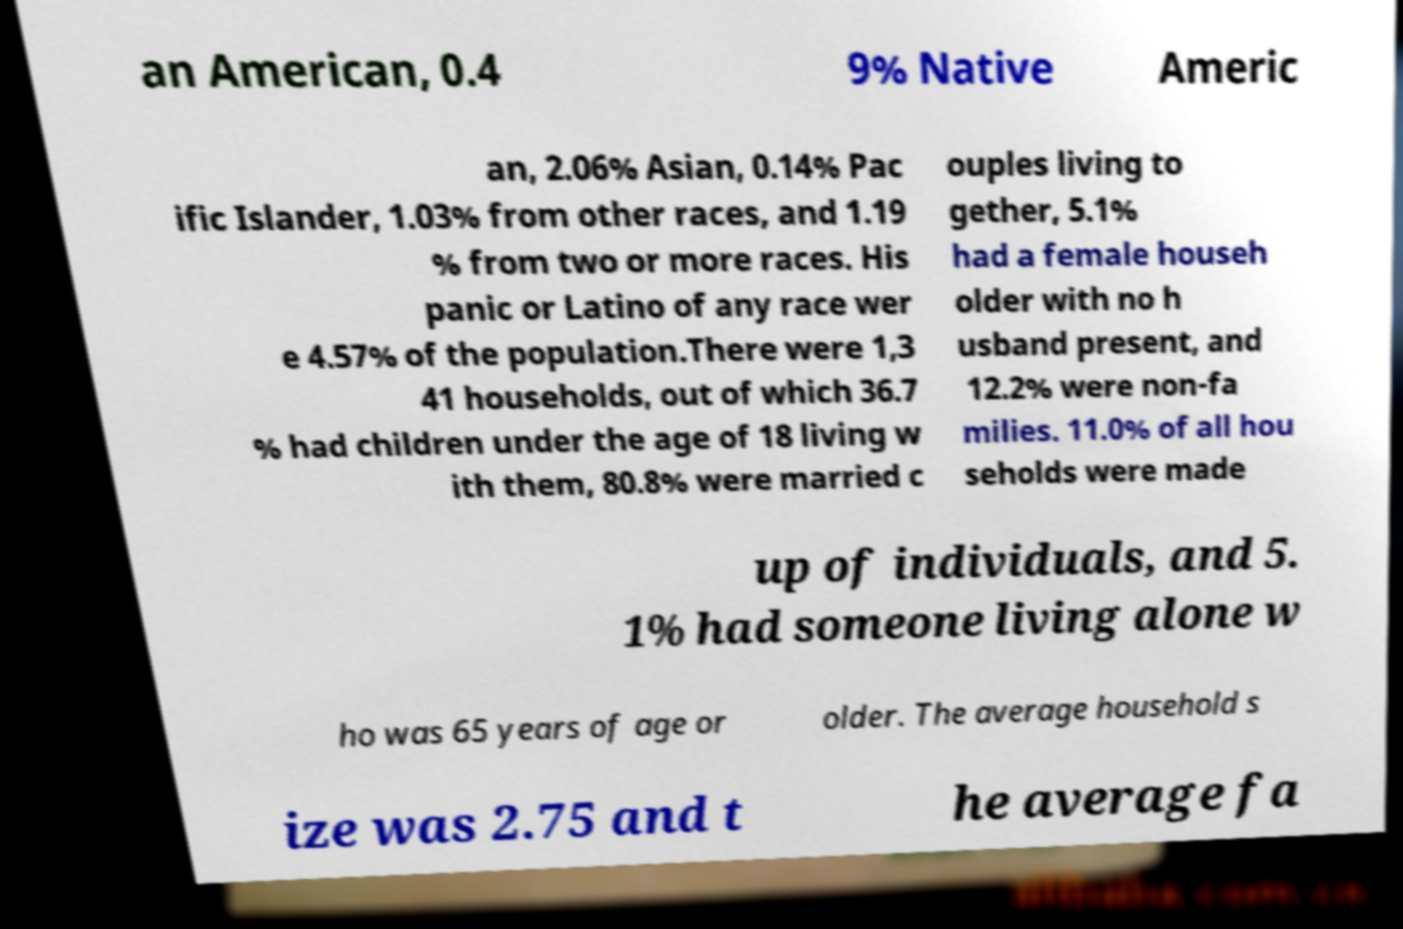Could you extract and type out the text from this image? an American, 0.4 9% Native Americ an, 2.06% Asian, 0.14% Pac ific Islander, 1.03% from other races, and 1.19 % from two or more races. His panic or Latino of any race wer e 4.57% of the population.There were 1,3 41 households, out of which 36.7 % had children under the age of 18 living w ith them, 80.8% were married c ouples living to gether, 5.1% had a female househ older with no h usband present, and 12.2% were non-fa milies. 11.0% of all hou seholds were made up of individuals, and 5. 1% had someone living alone w ho was 65 years of age or older. The average household s ize was 2.75 and t he average fa 